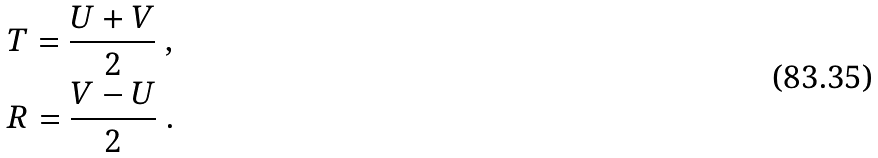<formula> <loc_0><loc_0><loc_500><loc_500>& T = \frac { U + V } { 2 } \ , \\ & R = \frac { V - U } { 2 } \ .</formula> 